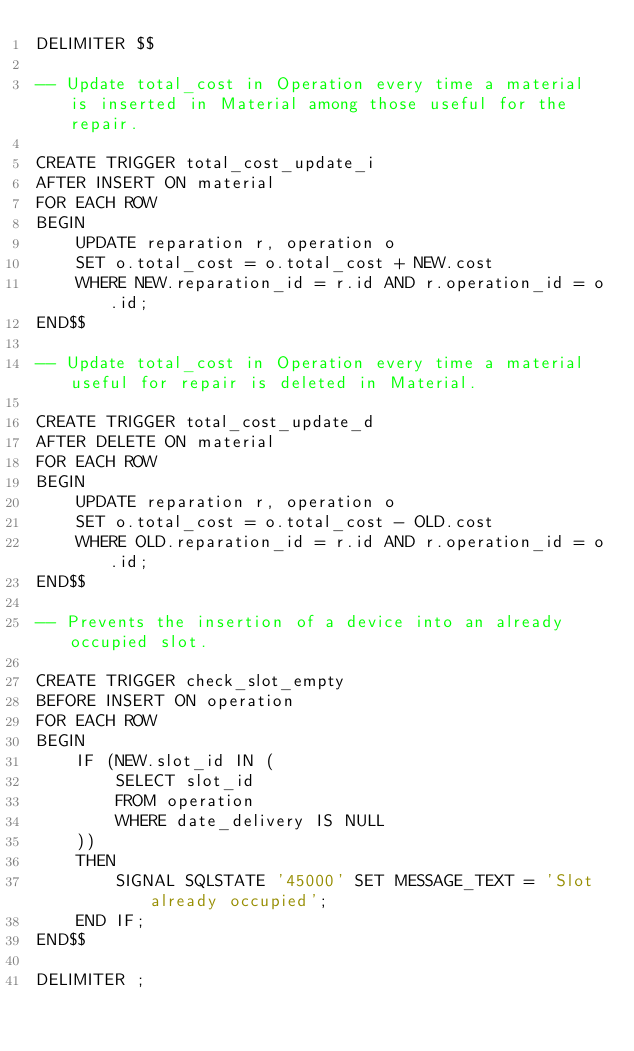<code> <loc_0><loc_0><loc_500><loc_500><_SQL_>DELIMITER $$  

-- Update total_cost in Operation every time a material is inserted in Material among those useful for the repair. 

CREATE TRIGGER total_cost_update_i
AFTER INSERT ON material
FOR EACH ROW 
BEGIN
    UPDATE reparation r, operation o
    SET o.total_cost = o.total_cost + NEW.cost
    WHERE NEW.reparation_id = r.id AND r.operation_id = o.id;
END$$

-- Update total_cost in Operation every time a material useful for repair is deleted in Material.

CREATE TRIGGER total_cost_update_d
AFTER DELETE ON material
FOR EACH ROW 
BEGIN
    UPDATE reparation r, operation o
    SET o.total_cost = o.total_cost - OLD.cost
    WHERE OLD.reparation_id = r.id AND r.operation_id = o.id;
END$$

-- Prevents the insertion of a device into an already occupied slot.

CREATE TRIGGER check_slot_empty
BEFORE INSERT ON operation
FOR EACH ROW
BEGIN
    IF (NEW.slot_id IN ( 
        SELECT slot_id
        FROM operation
        WHERE date_delivery IS NULL
    )) 
    THEN
        SIGNAL SQLSTATE '45000' SET MESSAGE_TEXT = 'Slot already occupied';
    END IF;
END$$

DELIMITER ;
</code> 